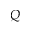<formula> <loc_0><loc_0><loc_500><loc_500>Q</formula> 